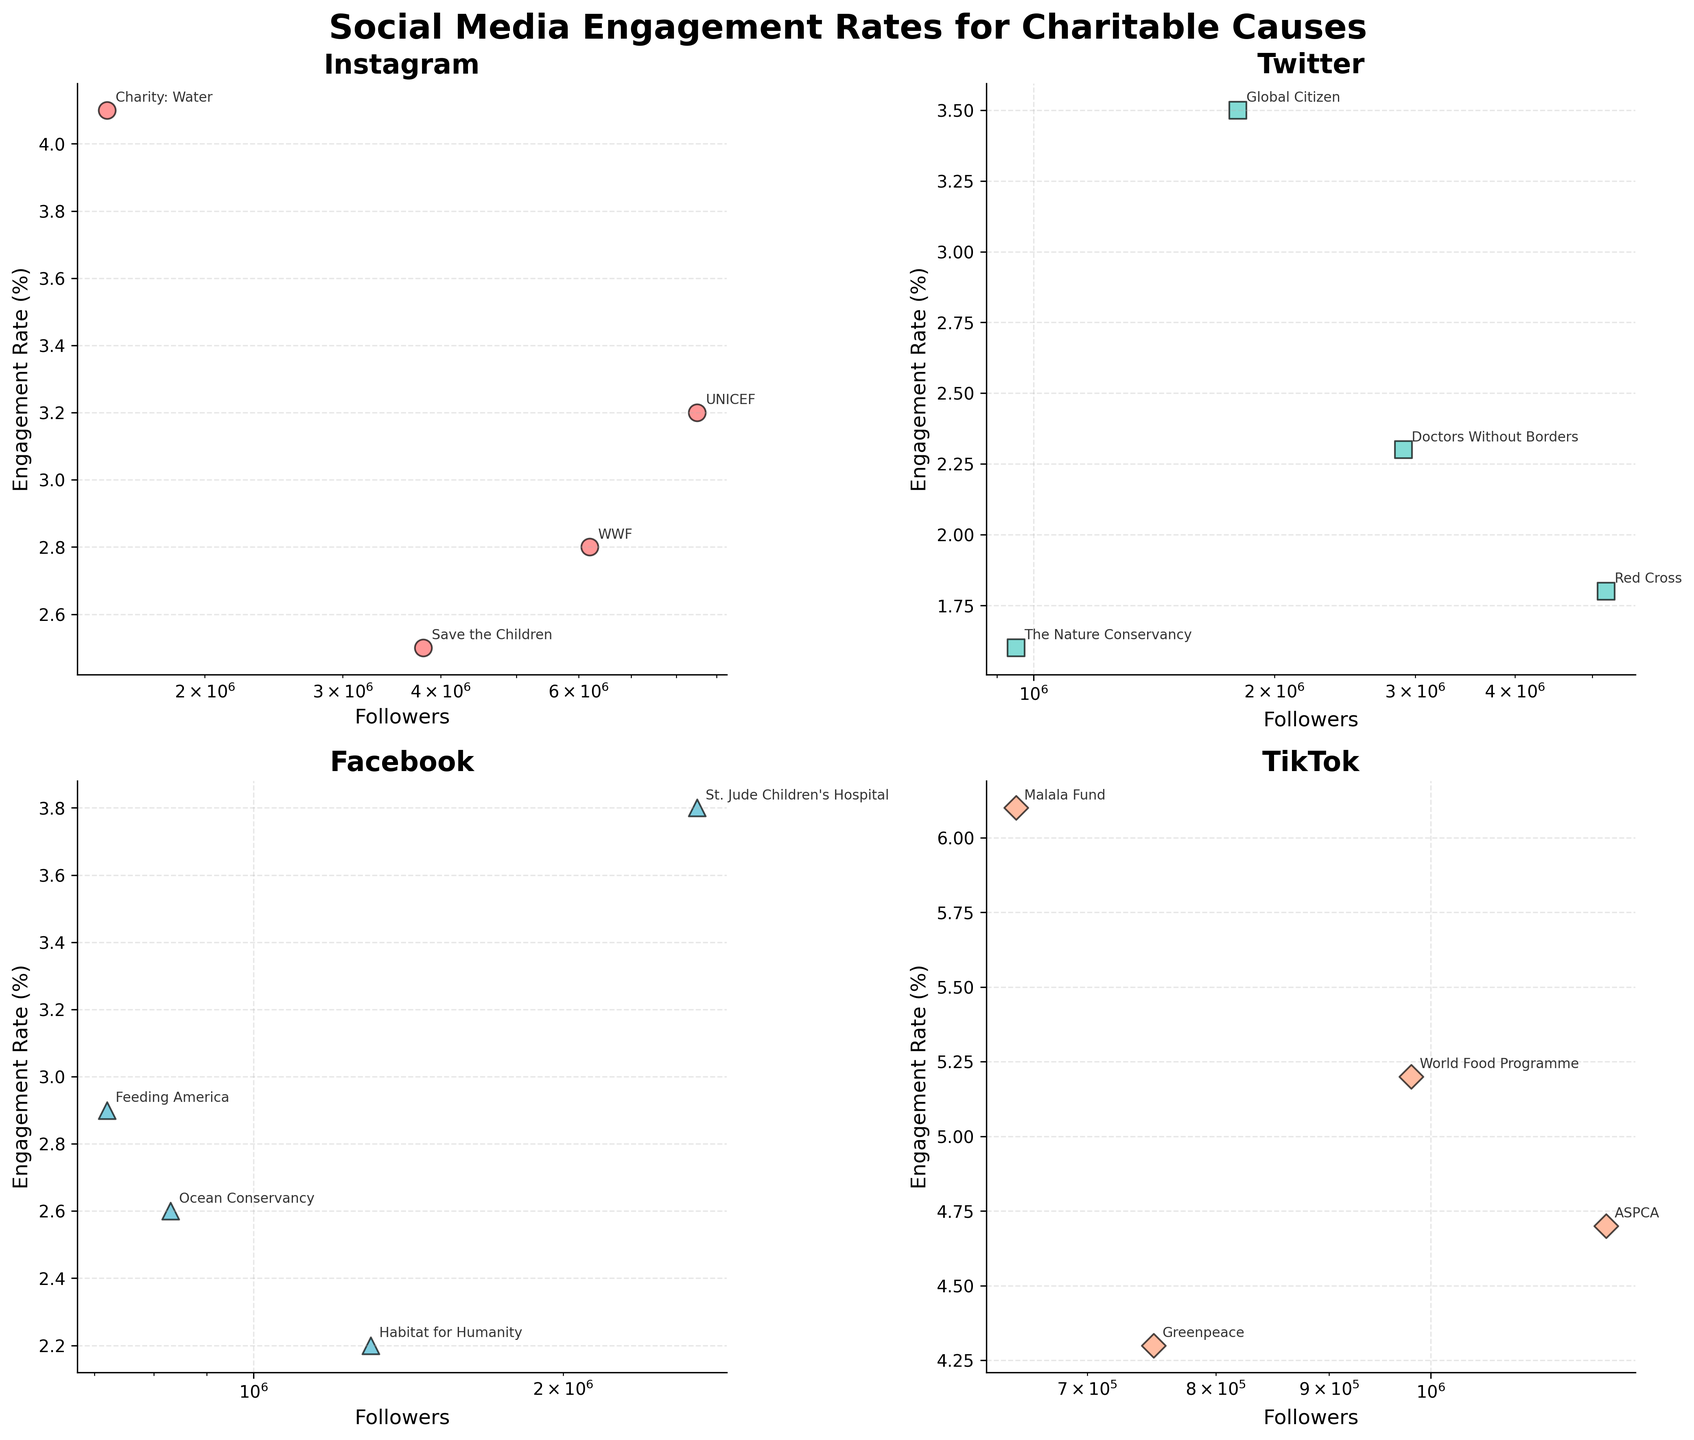What is the engagement rate of UNICEF on Instagram? To find the engagement rate of UNICEF on Instagram, look at the scatter plot for Instagram and find the point labeled "UNICEF". The engagement rate is the y-value of that point.
Answer: 3.2 Which charitable cause has the highest engagement rate on TikTok? Look at the TikTok scatter plot and identify the point with the highest y-value. Check the label of that point to find the corresponding charitable cause.
Answer: Malala Fund How many charitable causes are analyzed for each social media platform? Each scatter plot represents a different platform. Count the number of labeled points in any one scatter plot to find the number of charitable causes analyzed for each platform.
Answer: 4 Which platform has the overall highest engagement rate for a charitable cause, and what is that rate? Compare the highest y-values across all four scatter plots. The highest engagement rate occurs in one of the scatter plots. Check the associated platform and rate.
Answer: TikTok, 6.1 What is the difference in engagement rate between the WWF on Instagram and Doctors Without Borders on Twitter? Locate the points labeled "WWF" on Instagram and "Doctors Without Borders" on Twitter, note their y-values, and subtract the engagement rate of Doctors Without Borders from that of WWF.
Answer: 0.5 Which platform has the most charitable causes with engagement rates above 3%? For each of the four scatter plots, count the number of points with y-values (engagement rates) above 3%. Determine which plot has the highest count.
Answer: TikTok Are there more followers for environmental causes on Instagram or Facebook? Identify the points associated with environmental causes on both Instagram and Facebook scatter plots. Compare their follower counts (x-values) to determine which platform has more followers for these causes.
Answer: Instagram What is the general trend in engagement rates for causes with higher follower counts on Twitter? Examine the Twitter scatter plot and observe the distribution of engagement rates as follower counts increase. Note whether there's an upward, downward, or no discernible trend.
Answer: Downward Which has a higher engagement rate, Save the Children on Instagram or St. Jude Children's Hospital on Facebook? Locate the points for "Save the Children" on Instagram and "St. Jude Children's Hospital" on Facebook, and compare their y-values (engagement rates).
Answer: St. Jude Children's Hospital Compare the average engagement rate of all charitable causes on TikTok to those on Facebook. Calculate the average engagement rate for TikTok by adding all the y-values in the TikTok plot and dividing by the number of points. Repeat for Facebook and compare the two averages.
Answer: TikTok has a higher average engagement rate 